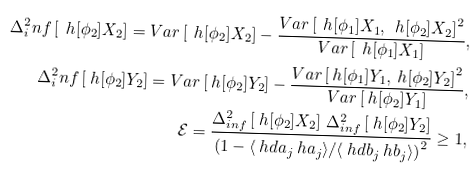Convert formula to latex. <formula><loc_0><loc_0><loc_500><loc_500>\Delta ^ { 2 } _ { i } n f \left [ \ h [ \phi _ { 2 } ] { X } _ { 2 } \right ] = V a r \left [ \ h [ \phi _ { 2 } ] { X } _ { 2 } \right ] - \frac { V a r \left [ \ h [ \phi _ { 1 } ] { X } _ { 1 } , \ h [ \phi _ { 2 } ] { X } _ { 2 } \right ] ^ { 2 } } { V a r \left [ \ h [ \phi _ { 1 } ] { X } _ { 1 } \right ] } , \\ \Delta ^ { 2 } _ { i } n f \left [ \ h [ \phi _ { 2 } ] { Y } _ { 2 } \right ] = V a r \left [ \ h [ \phi _ { 2 } ] { Y } _ { 2 } \right ] - \frac { V a r \left [ \ h [ \phi _ { 1 } ] { Y } _ { 1 } , \ h [ \phi _ { 2 } ] { Y } _ { 2 } \right ] ^ { 2 } } { V a r \left [ \ h [ \phi _ { 2 } ] { Y } _ { 1 } \right ] } , \\ \mathcal { E } = \frac { \Delta _ { i n f } ^ { 2 } \left [ \ h [ \phi _ { 2 } ] { X } _ { 2 } \right ] \, \Delta _ { i n f } ^ { 2 } \left [ \ h [ \phi _ { 2 } ] { Y } _ { 2 } \right ] } { \left ( 1 - \langle \ h d { a } _ { j } \ h { a } _ { j } \rangle / \langle \ h d { b } _ { j } \ h { b } _ { j } \rangle \right ) ^ { 2 } } \geq 1 ,</formula> 